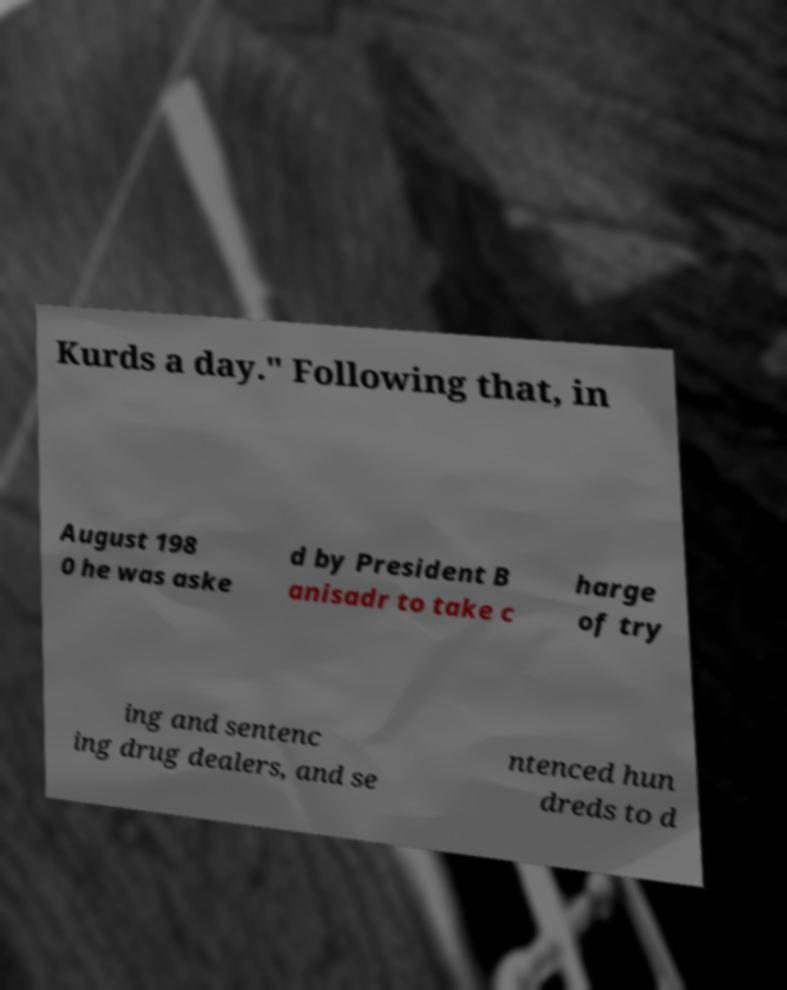Please read and relay the text visible in this image. What does it say? Kurds a day." Following that, in August 198 0 he was aske d by President B anisadr to take c harge of try ing and sentenc ing drug dealers, and se ntenced hun dreds to d 